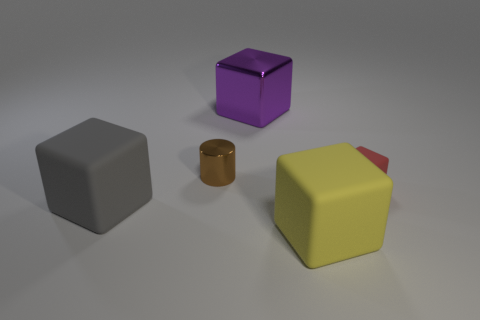Are there any small brown metal objects?
Your answer should be compact. Yes. What size is the red block that is made of the same material as the yellow cube?
Your answer should be very brief. Small. Are there any large shiny cylinders that have the same color as the metal cube?
Offer a very short reply. No. Is the color of the big thing that is behind the red rubber thing the same as the small object to the left of the red matte block?
Provide a succinct answer. No. Are there any large gray blocks that have the same material as the red thing?
Your response must be concise. Yes. The small matte thing has what color?
Keep it short and to the point. Red. There is a matte object left of the big matte thing that is right of the shiny object behind the brown cylinder; how big is it?
Your answer should be compact. Large. How many other objects are there of the same shape as the purple metallic thing?
Offer a terse response. 3. What color is the big thing that is on the left side of the yellow thing and in front of the big metallic object?
Your response must be concise. Gray. How many cubes are yellow rubber objects or red rubber things?
Provide a succinct answer. 2. 